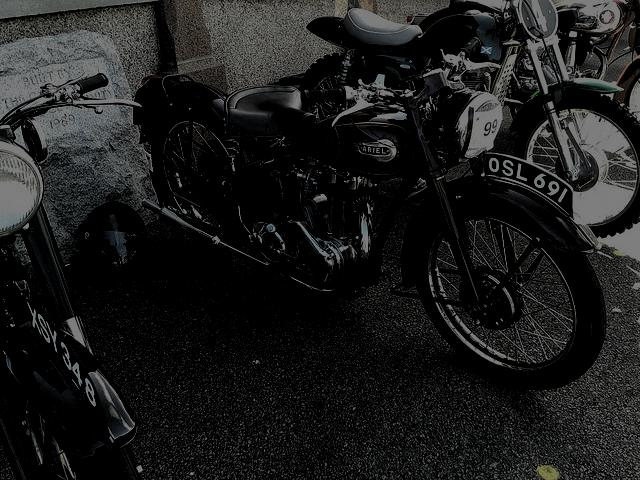What's the likely cultural significance of a motorcycle like this? Vintage motorcycles like the one shown in the image are icons of a bygone era. They evoke a sense of nostalgia and are emblematic of the freedom and adventure associated with the open road. Collectors and enthusiasts often celebrate these machines through restoration and at events like classic motorcycle shows. They also reflect an era of mechanical simplicity and craft, contrasting with today's more technology-driven designs. 